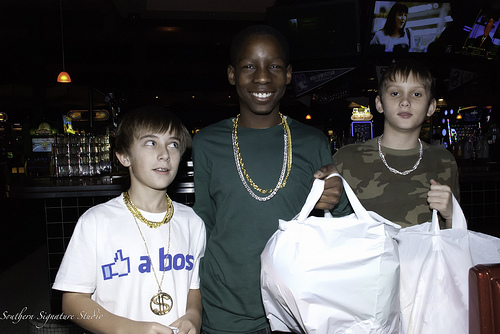<image>
Can you confirm if the necklace is in front of the bag? No. The necklace is not in front of the bag. The spatial positioning shows a different relationship between these objects. 